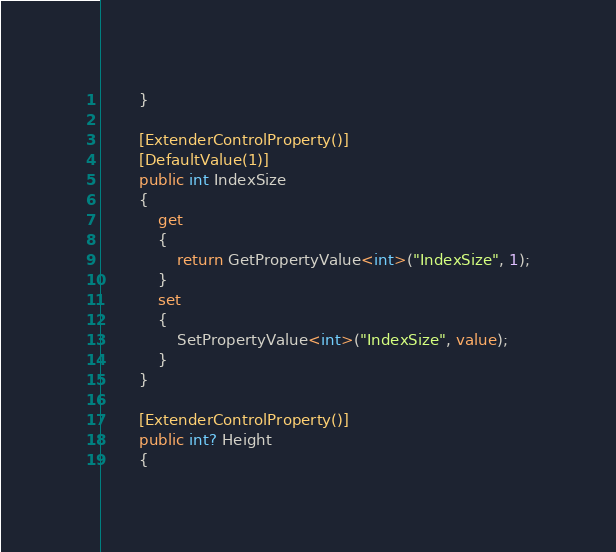<code> <loc_0><loc_0><loc_500><loc_500><_C#_>        }

        [ExtenderControlProperty()]
        [DefaultValue(1)]
        public int IndexSize
        {
            get
            {
                return GetPropertyValue<int>("IndexSize", 1);
            }
            set
            {
                SetPropertyValue<int>("IndexSize", value);
            }
        }

        [ExtenderControlProperty()]
        public int? Height
        {</code> 